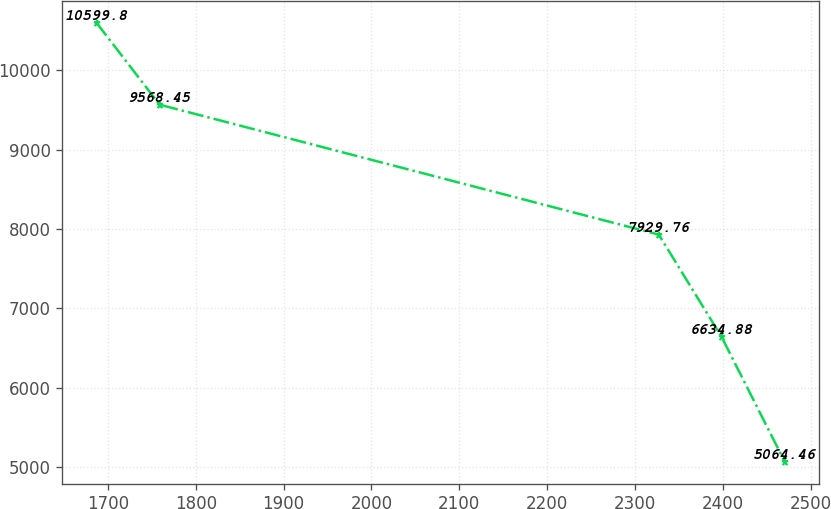Convert chart. <chart><loc_0><loc_0><loc_500><loc_500><line_chart><ecel><fcel>Unnamed: 1<nl><fcel>1687.05<fcel>10599.8<nl><fcel>1758.77<fcel>9568.45<nl><fcel>2327.1<fcel>7929.76<nl><fcel>2398.82<fcel>6634.88<nl><fcel>2470.54<fcel>5064.46<nl></chart> 